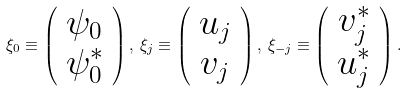<formula> <loc_0><loc_0><loc_500><loc_500>\xi _ { 0 } \equiv \left ( \begin{array} { c } \psi _ { 0 } \\ \psi ^ { * } _ { 0 } \end{array} \right ) , \, \xi _ { j } \equiv \left ( \begin{array} { c } u _ { j } \\ v _ { j } \end{array} \right ) , \, \xi _ { - j } \equiv \left ( \begin{array} { c } v ^ { * } _ { j } \\ u ^ { * } _ { j } \end{array} \right ) .</formula> 